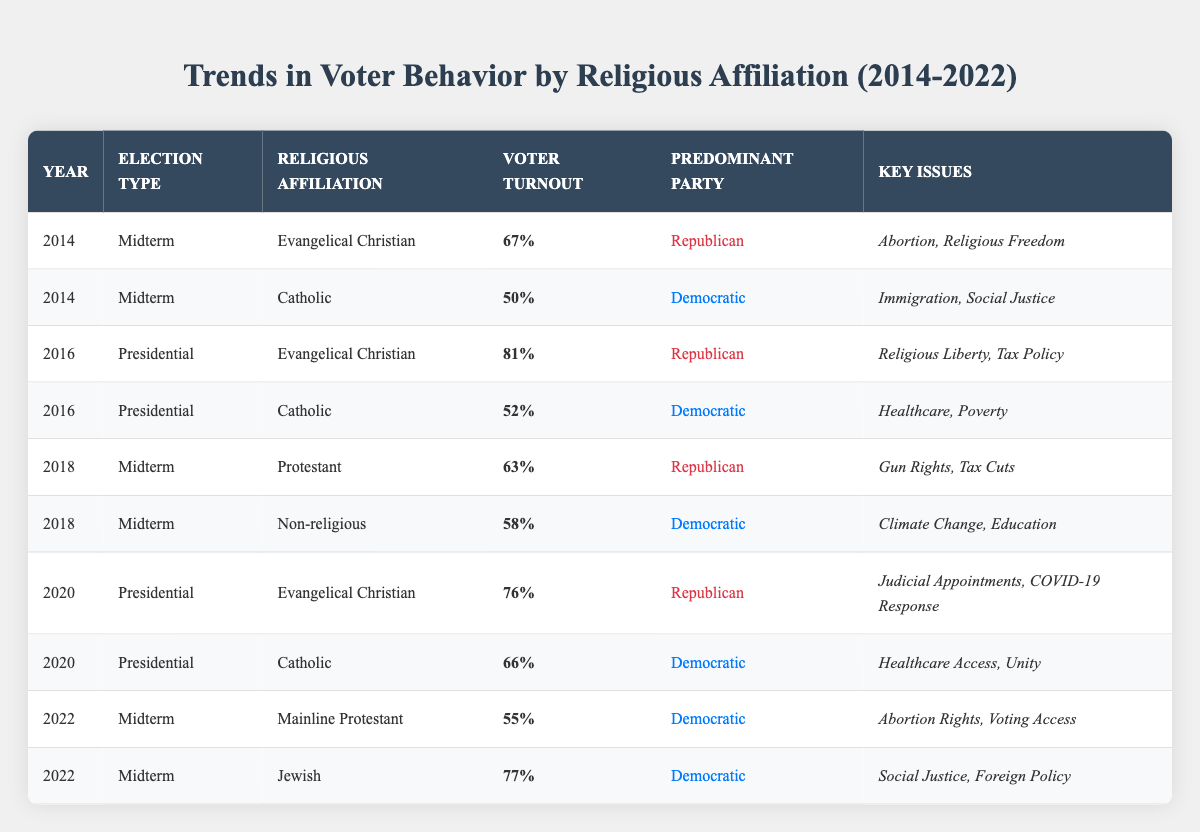What was the voter turnout percentage for Evangelical Christians in the 2016 Presidential election? In the table, look at the row where the year is 2016 and the election type is Presidential, and where the religious affiliation is Evangelical Christian. The voter turnout percentage listed there is 81%.
Answer: 81% Which religious affiliation had the lowest voter turnout in the 2018 Midterm elections? To answer this, I will check the voter turnout percentages for the religious affiliations listed under the 2018 Midterm elections. The percentages are 63% for Protestant and 58% for Non-religious. Thus, Non-religious had the lowest turnout.
Answer: Non-religious What is the difference in voter turnout percentage between Catholics in the 2020 Presidential election and Evangelical Christians in the same election? First, find the voter turnout percentage for Catholics in 2020, which is 66%. Then, find the percentage for Evangelical Christians in 2020, which is 76%. The difference is 76% - 66% = 10%.
Answer: 10% Did Jewish voters predominantly support the Democratic party in the 2022 Midterm elections? Looking at the 2022 Midterm election row for Jewish voters, the predominant party listed is Democratic. Therefore, this statement is true.
Answer: Yes What was the average voter turnout percentage for Catholics across all mentioned elections (2014, 2016, 2020)? Calculate the average by first finding the voter turnout percentages for Catholics in each election: 50% in 2014, 52% in 2016, and 66% in 2020. Sum them up: 50 + 52 + 66 = 168. There are 3 elections, so divide by 3: 168 / 3 = 56.
Answer: 56 